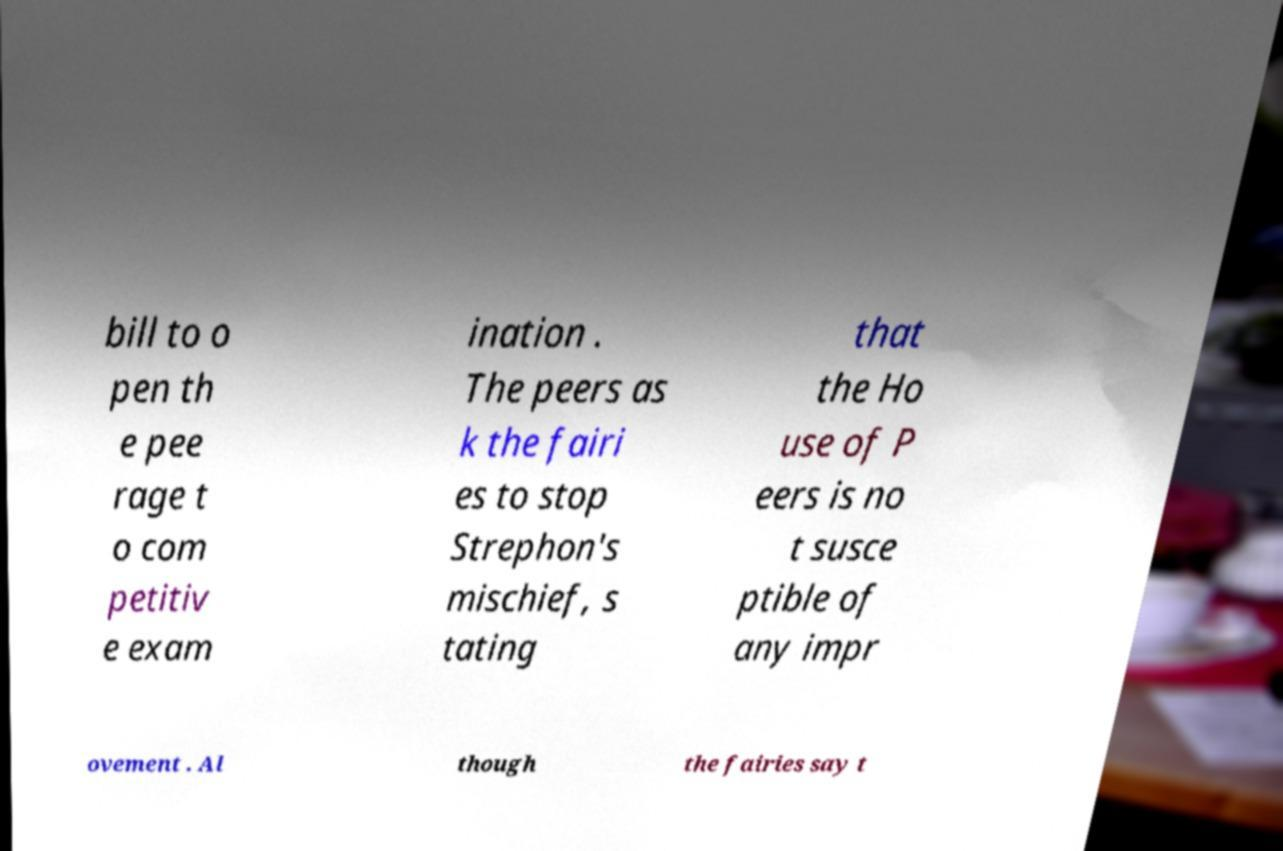Could you extract and type out the text from this image? bill to o pen th e pee rage t o com petitiv e exam ination . The peers as k the fairi es to stop Strephon's mischief, s tating that the Ho use of P eers is no t susce ptible of any impr ovement . Al though the fairies say t 